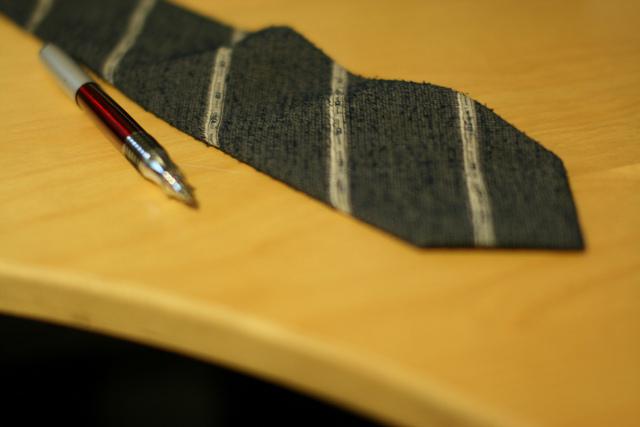How many items are in this photo?
Write a very short answer. 2. What type of markers are on the desk?
Be succinct. Pen. What is this tool used for?
Keep it brief. Writing. Do the pen and tie match in length?
Quick response, please. No. What colors are the tie?
Answer briefly. Gray and white. What is next to the tie?
Short answer required. Pen. 